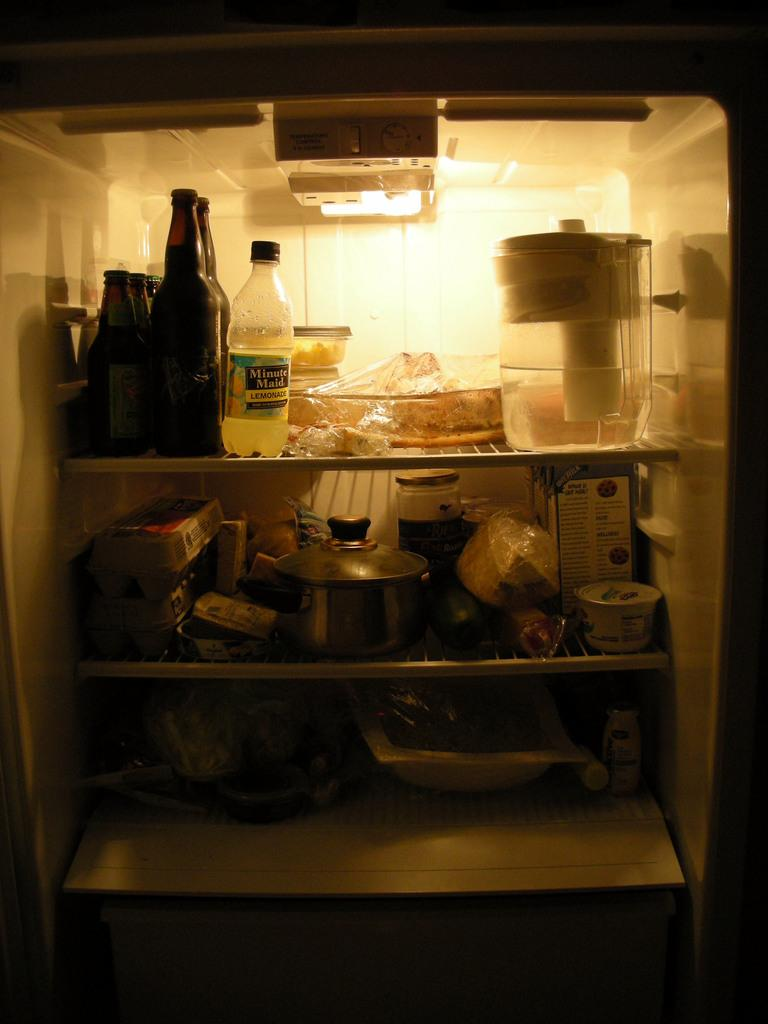What type of appliance is visible in the image? There is a fridge in the image. What items are stored inside the fridge? Bottles are kept inside the fridge. Can you describe another object in the image? There is a steel pot in the image. What is the price of the finger shown in the image? There is no finger present in the image, so it is not possible to determine its price. 